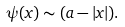<formula> <loc_0><loc_0><loc_500><loc_500>\psi ( x ) \sim ( a - | x | ) .</formula> 